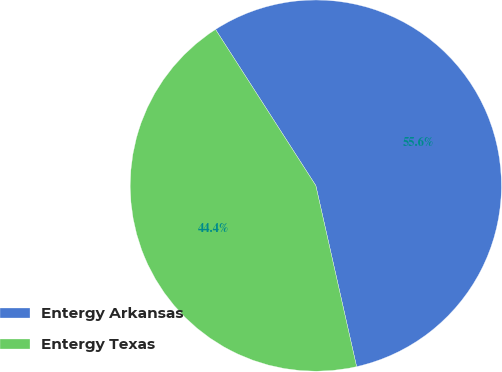Convert chart to OTSL. <chart><loc_0><loc_0><loc_500><loc_500><pie_chart><fcel>Entergy Arkansas<fcel>Entergy Texas<nl><fcel>55.56%<fcel>44.44%<nl></chart> 